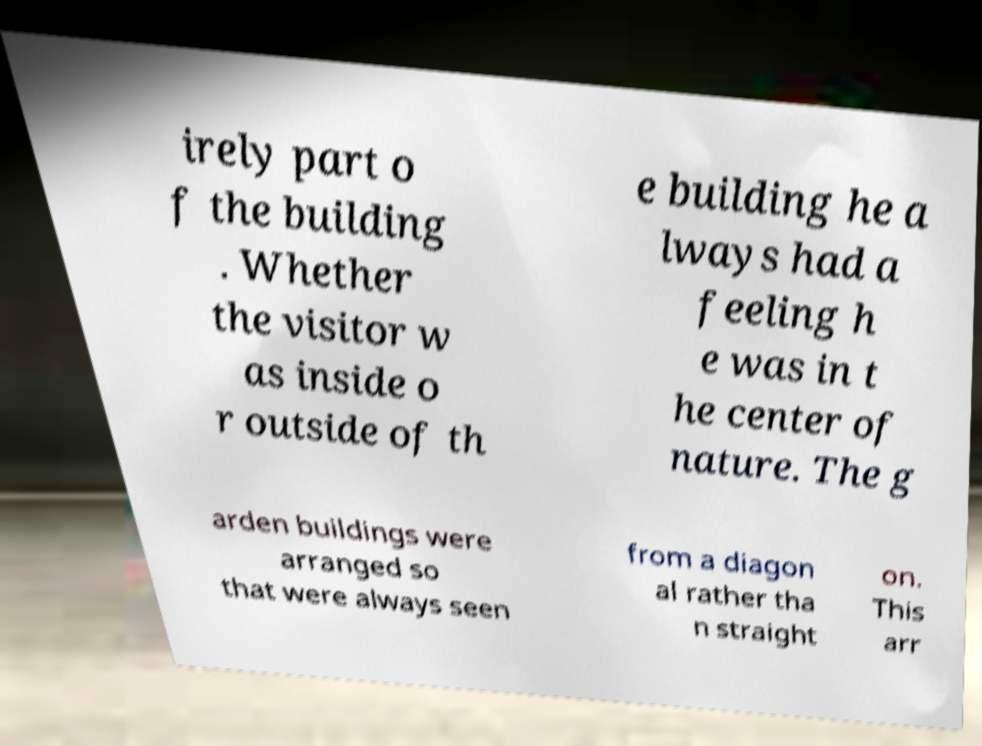Can you accurately transcribe the text from the provided image for me? irely part o f the building . Whether the visitor w as inside o r outside of th e building he a lways had a feeling h e was in t he center of nature. The g arden buildings were arranged so that were always seen from a diagon al rather tha n straight on. This arr 